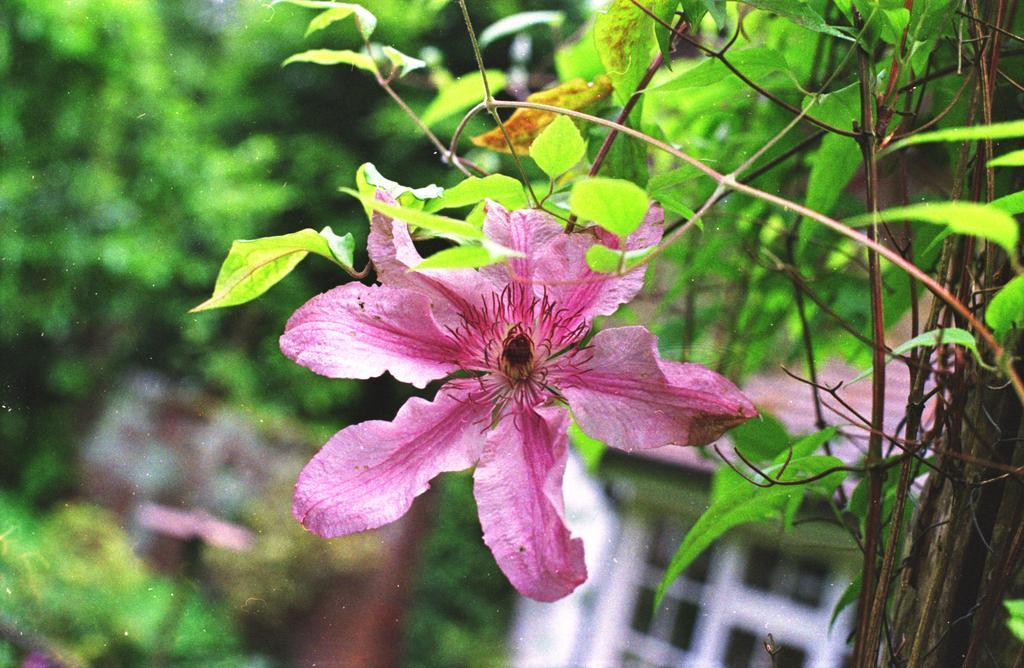How would you summarize this image in a sentence or two? In this image there is a plant having a flower and few leaves. Right bottom a window is visible. Background is blurry. 